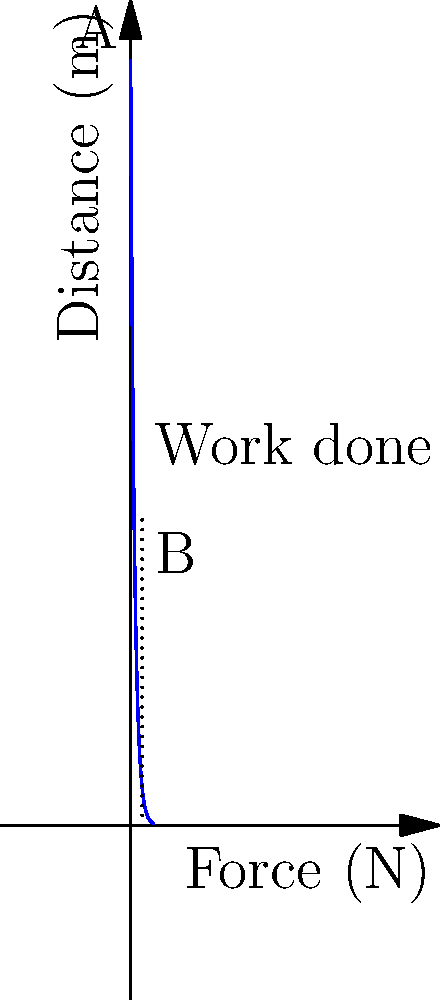As a parent supervising your child on a spring rider at the playground, you notice the force-distance relationship shown in the graph. If the spring compresses from point A to point B, what is the approximate work done by the child? To calculate the work done, we need to follow these steps:

1. Understand that work is the area under the force-distance curve.
2. Identify the initial and final points:
   Point A: (0 m, 100 N)
   Point B: (1.5 m, 40 N)
3. Approximate the area under the curve as a trapezoid:
   Area = $\frac{1}{2}$ (base) (height1 + height2)
4. Calculate:
   Base = 1.5 m
   Height1 = 100 N
   Height2 = 40 N
   Work = $\frac{1}{2}$ (1.5 m) (100 N + 40 N)
   Work = 0.75 m × 140 N = 105 J

The work done is approximately 105 Joules.

This calculation helps parents understand the energy expenditure and muscle engagement of their children while using playground equipment, which is relevant for both safety and physical development considerations.
Answer: 105 J 